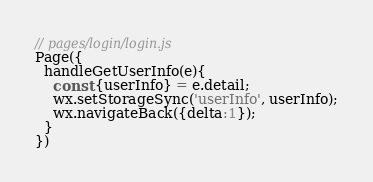Convert code to text. <code><loc_0><loc_0><loc_500><loc_500><_JavaScript_>// pages/login/login.js
Page({
  handleGetUserInfo(e){
    const {userInfo} = e.detail;
    wx.setStorageSync('userInfo', userInfo);
    wx.navigateBack({delta:1});
  }
})</code> 